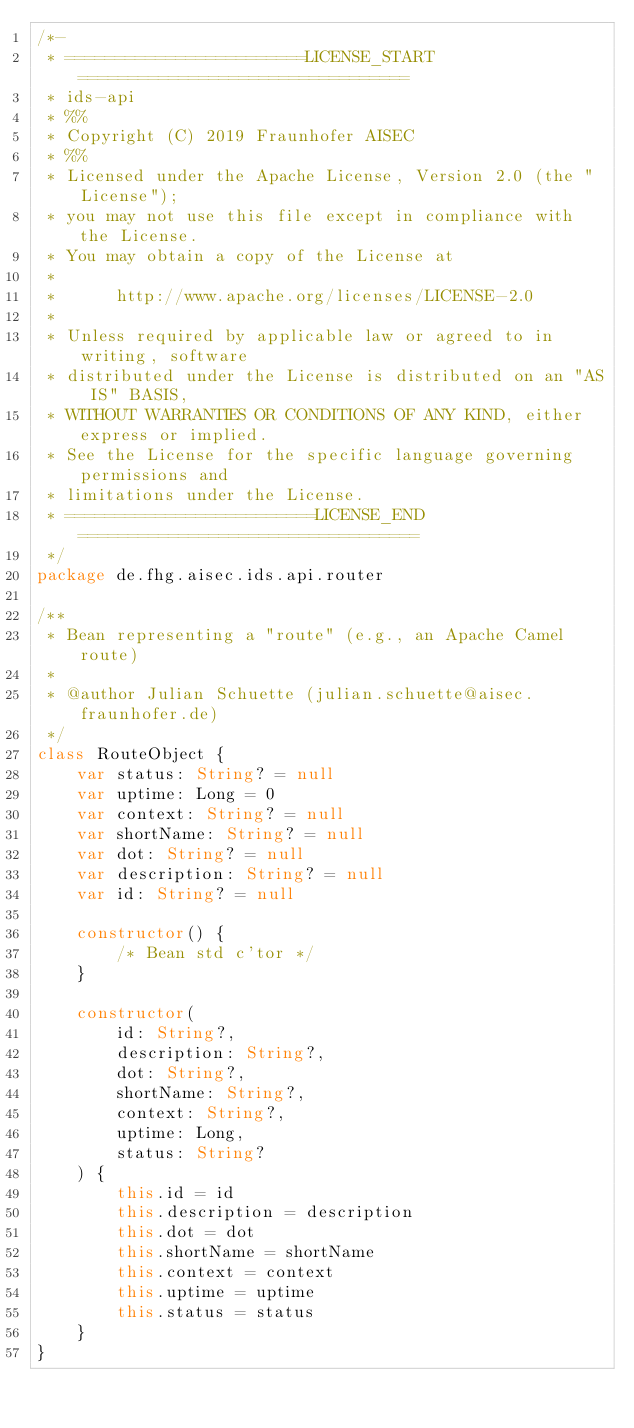<code> <loc_0><loc_0><loc_500><loc_500><_Kotlin_>/*-
 * ========================LICENSE_START=================================
 * ids-api
 * %%
 * Copyright (C) 2019 Fraunhofer AISEC
 * %%
 * Licensed under the Apache License, Version 2.0 (the "License");
 * you may not use this file except in compliance with the License.
 * You may obtain a copy of the License at
 *
 *      http://www.apache.org/licenses/LICENSE-2.0
 *
 * Unless required by applicable law or agreed to in writing, software
 * distributed under the License is distributed on an "AS IS" BASIS,
 * WITHOUT WARRANTIES OR CONDITIONS OF ANY KIND, either express or implied.
 * See the License for the specific language governing permissions and
 * limitations under the License.
 * =========================LICENSE_END==================================
 */
package de.fhg.aisec.ids.api.router

/**
 * Bean representing a "route" (e.g., an Apache Camel route)
 *
 * @author Julian Schuette (julian.schuette@aisec.fraunhofer.de)
 */
class RouteObject {
    var status: String? = null
    var uptime: Long = 0
    var context: String? = null
    var shortName: String? = null
    var dot: String? = null
    var description: String? = null
    var id: String? = null

    constructor() {
        /* Bean std c'tor */
    }

    constructor(
        id: String?,
        description: String?,
        dot: String?,
        shortName: String?,
        context: String?,
        uptime: Long,
        status: String?
    ) {
        this.id = id
        this.description = description
        this.dot = dot
        this.shortName = shortName
        this.context = context
        this.uptime = uptime
        this.status = status
    }
}
</code> 